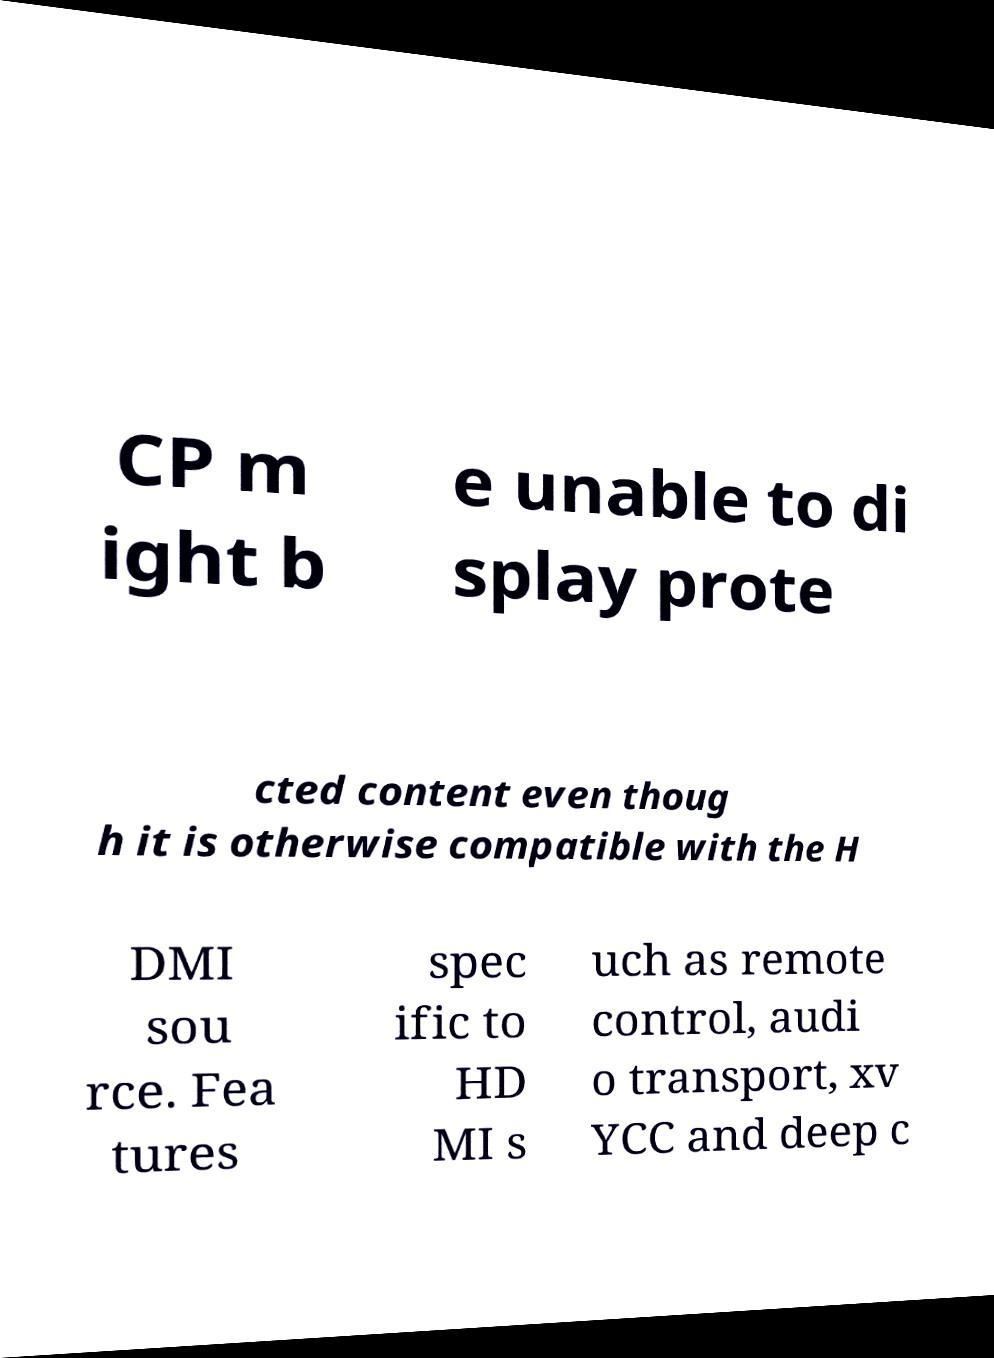Can you read and provide the text displayed in the image?This photo seems to have some interesting text. Can you extract and type it out for me? CP m ight b e unable to di splay prote cted content even thoug h it is otherwise compatible with the H DMI sou rce. Fea tures spec ific to HD MI s uch as remote control, audi o transport, xv YCC and deep c 